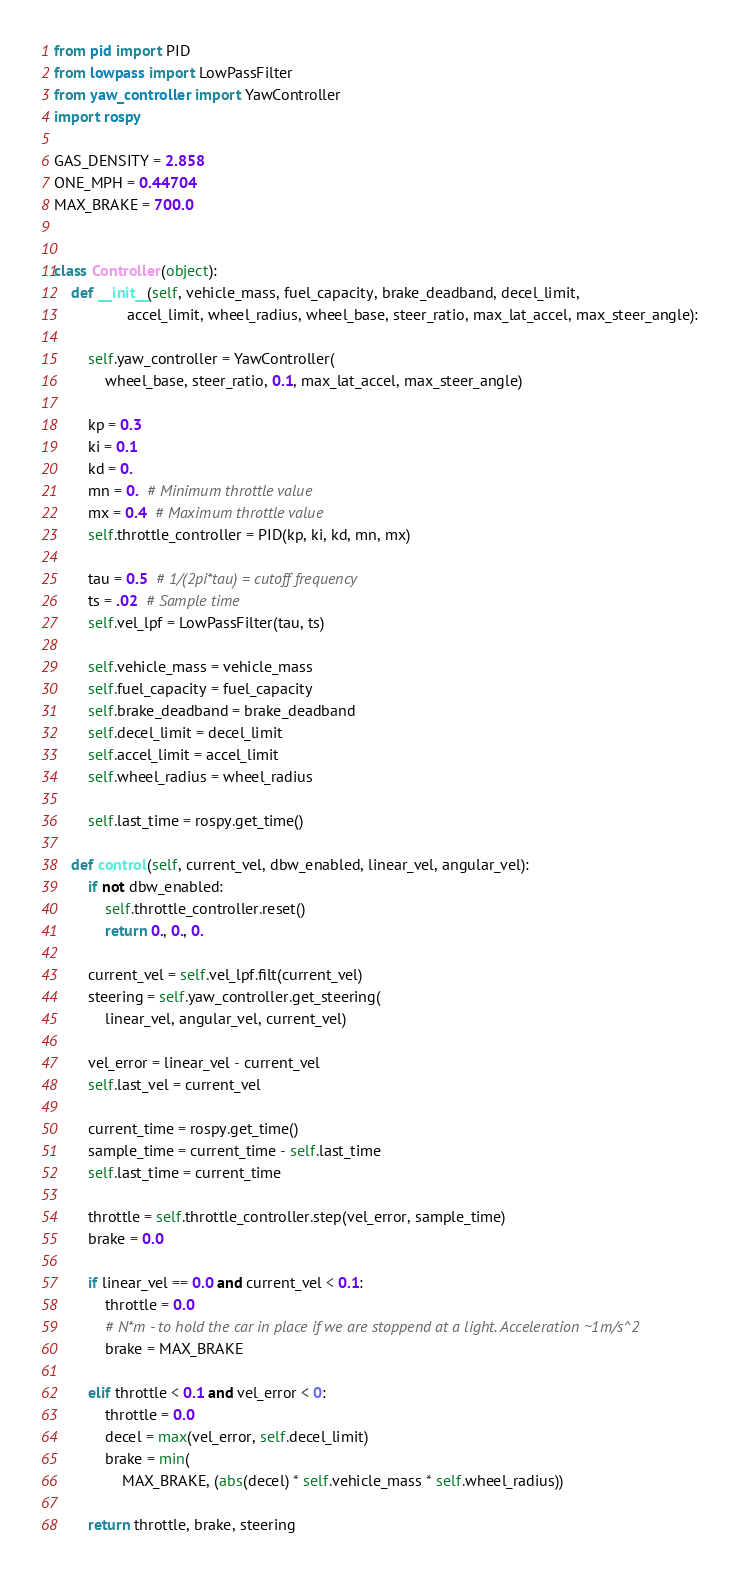<code> <loc_0><loc_0><loc_500><loc_500><_Python_>from pid import PID
from lowpass import LowPassFilter
from yaw_controller import YawController
import rospy

GAS_DENSITY = 2.858
ONE_MPH = 0.44704
MAX_BRAKE = 700.0


class Controller(object):
    def __init__(self, vehicle_mass, fuel_capacity, brake_deadband, decel_limit,
                 accel_limit, wheel_radius, wheel_base, steer_ratio, max_lat_accel, max_steer_angle):

        self.yaw_controller = YawController(
            wheel_base, steer_ratio, 0.1, max_lat_accel, max_steer_angle)

        kp = 0.3
        ki = 0.1
        kd = 0.
        mn = 0.  # Minimum throttle value
        mx = 0.4  # Maximum throttle value
        self.throttle_controller = PID(kp, ki, kd, mn, mx)

        tau = 0.5  # 1/(2pi*tau) = cutoff frequency
        ts = .02  # Sample time
        self.vel_lpf = LowPassFilter(tau, ts)

        self.vehicle_mass = vehicle_mass
        self.fuel_capacity = fuel_capacity
        self.brake_deadband = brake_deadband
        self.decel_limit = decel_limit
        self.accel_limit = accel_limit
        self.wheel_radius = wheel_radius

        self.last_time = rospy.get_time()

    def control(self, current_vel, dbw_enabled, linear_vel, angular_vel):
        if not dbw_enabled:
            self.throttle_controller.reset()
            return 0., 0., 0.

        current_vel = self.vel_lpf.filt(current_vel)
        steering = self.yaw_controller.get_steering(
            linear_vel, angular_vel, current_vel)

        vel_error = linear_vel - current_vel
        self.last_vel = current_vel

        current_time = rospy.get_time()
        sample_time = current_time - self.last_time
        self.last_time = current_time

        throttle = self.throttle_controller.step(vel_error, sample_time)
        brake = 0.0

        if linear_vel == 0.0 and current_vel < 0.1:
            throttle = 0.0
            # N*m - to hold the car in place if we are stoppend at a light. Acceleration ~1m/s^2
            brake = MAX_BRAKE

        elif throttle < 0.1 and vel_error < 0:
            throttle = 0.0
            decel = max(vel_error, self.decel_limit)
            brake = min(
                MAX_BRAKE, (abs(decel) * self.vehicle_mass * self.wheel_radius))

        return throttle, brake, steering
</code> 